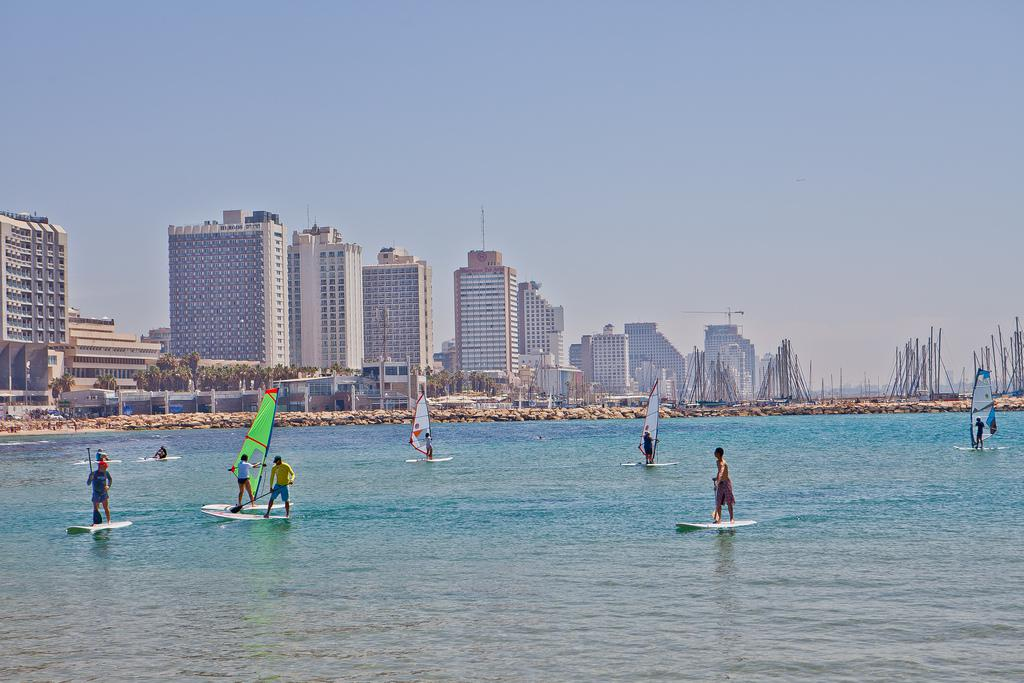Question: what is multi-story?
Choices:
A. Ferris wheel.
B. Cruise ship.
C. Double-decker bus.
D. Buildings.
Answer with the letter. Answer: D Question: what type of body of water is in this photo?
Choices:
A. A harbor.
B. A lake.
C. A stream.
D. A river.
Answer with the letter. Answer: A Question: what is behind the beach?
Choices:
A. Buildings.
B. Cliffs.
C. The boardwalk.
D. Shopping centers.
Answer with the letter. Answer: A Question: where are these people surfboarding?
Choices:
A. The Pacific ocean.
B. The Atlantic ocean.
C. At a beach.
D. They're in the Bahamas.
Answer with the letter. Answer: C Question: what is in the background?
Choices:
A. Trees.
B. Buildings.
C. Open sky.
D. Corn fields.
Answer with the letter. Answer: B Question: when will it be night time?
Choices:
A. Soon.
B. At dusk.
C. When it gets dark.
D. About 7 p.m.
Answer with the letter. Answer: A Question: what are the people doing in the water?
Choices:
A. Swimming.
B. Surfboarding.
C. Floating.
D. Jet skiing.
Answer with the letter. Answer: B Question: why are these people surfing?
Choices:
A. They wanted to learn.
B. They like to surf.
C. It's a lot of fun.
D. They love to be in the ocean.
Answer with the letter. Answer: B Question: what does the sky look like in the photo?
Choices:
A. Clear and blue.
B. Cloudy and gray.
C. Sunset and orange.
D. Snowy and grey.
Answer with the letter. Answer: A Question: how many surfers are in a yellow shirt?
Choices:
A. 5.
B. 6.
C. 7.
D. 1.
Answer with the letter. Answer: D Question: what does the city sky look like in this photo?
Choices:
A. Red and windy.
B. Orange and humid.
C. Blue and smoggy.
D. Green and wintry.
Answer with the letter. Answer: C Question: what is white?
Choices:
A. The surfboard.
B. The boats.
C. The tiles.
D. The cars.
Answer with the letter. Answer: A Question: what is outdoors?
Choices:
A. This photo.
B. A tree.
C. A car.
D. A parking lot.
Answer with the letter. Answer: A Question: what is bright green?
Choices:
A. The leaves.
B. The dog's collar.
C. One of the sails.
D. My new skirt.
Answer with the letter. Answer: C Question: what is bright green?
Choices:
A. One of the sails.
B. My car.
C. The boat.
D. Her shoes.
Answer with the letter. Answer: A Question: what is on the boards?
Choices:
A. Swim suits.
B. Shorts.
C. Kites.
D. Sails.
Answer with the letter. Answer: D Question: what was taken outdoors?
Choices:
A. The laundry.
B. The dog.
C. This picture.
D. The chairs.
Answer with the letter. Answer: C Question: what is white?
Choices:
A. The house.
B. The car.
C. The surfboards.
D. The dog.
Answer with the letter. Answer: C Question: when was this scene taken?
Choices:
A. Daytime.
B. Noon.
C. Nighttime.
D. Afternoon.
Answer with the letter. Answer: A 